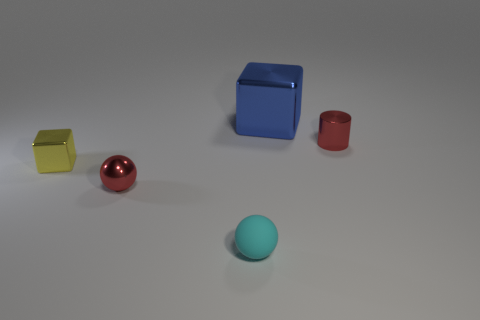What number of objects are tiny shiny things on the right side of the blue block or small gray cylinders?
Ensure brevity in your answer.  1. There is a small thing that is on the left side of the big blue metallic cube and behind the tiny red sphere; what is its shape?
Offer a terse response. Cube. Is there anything else that has the same size as the blue shiny object?
Your answer should be very brief. No. There is a cube that is made of the same material as the large object; what is its size?
Your answer should be compact. Small. What number of things are shiny things that are in front of the big blue thing or metallic blocks on the left side of the blue shiny block?
Your answer should be compact. 3. Do the red thing that is right of the blue object and the cyan object have the same size?
Make the answer very short. Yes. What color is the tiny thing behind the tiny block?
Make the answer very short. Red. There is another metal thing that is the same shape as the large blue object; what is its color?
Make the answer very short. Yellow. There is a red thing that is on the right side of the red metallic object left of the small rubber thing; what number of small yellow shiny blocks are to the left of it?
Ensure brevity in your answer.  1. Is there anything else that has the same material as the small cube?
Keep it short and to the point. Yes. 